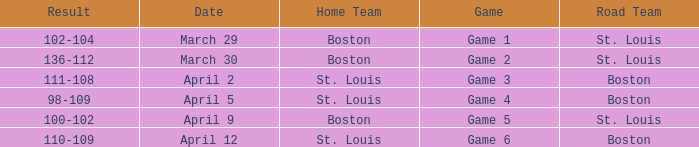What is the Result of Game 3? 111-108. 